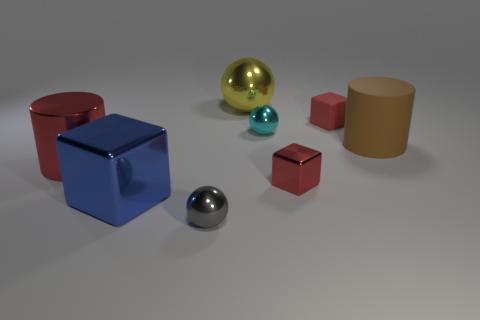What might the purpose of this image be? This image appears to be a computer-generated rendering that might be used to demonstrate different material properties like reflectiveness, matte surfaces, and shadows, as well as color and size contrasts among geometric shapes. It's a composition that can serve as a visual aid in tutorials about computer graphics or as a sample to exhibit the capabilities of rendering software. 